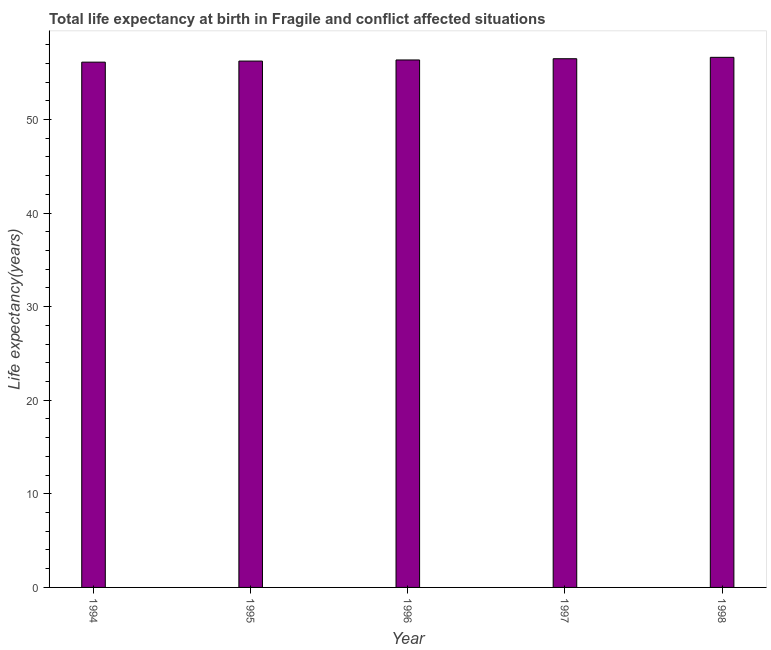Does the graph contain any zero values?
Give a very brief answer. No. Does the graph contain grids?
Offer a very short reply. No. What is the title of the graph?
Provide a succinct answer. Total life expectancy at birth in Fragile and conflict affected situations. What is the label or title of the X-axis?
Give a very brief answer. Year. What is the label or title of the Y-axis?
Offer a very short reply. Life expectancy(years). What is the life expectancy at birth in 1995?
Your answer should be very brief. 56.25. Across all years, what is the maximum life expectancy at birth?
Your answer should be compact. 56.65. Across all years, what is the minimum life expectancy at birth?
Provide a short and direct response. 56.13. In which year was the life expectancy at birth maximum?
Provide a succinct answer. 1998. In which year was the life expectancy at birth minimum?
Your answer should be very brief. 1994. What is the sum of the life expectancy at birth?
Ensure brevity in your answer.  281.9. What is the difference between the life expectancy at birth in 1994 and 1995?
Provide a succinct answer. -0.12. What is the average life expectancy at birth per year?
Your answer should be compact. 56.38. What is the median life expectancy at birth?
Keep it short and to the point. 56.37. Do a majority of the years between 1997 and 1996 (inclusive) have life expectancy at birth greater than 22 years?
Give a very brief answer. No. Is the life expectancy at birth in 1994 less than that in 1996?
Make the answer very short. Yes. Is the difference between the life expectancy at birth in 1995 and 1997 greater than the difference between any two years?
Your answer should be very brief. No. What is the difference between the highest and the second highest life expectancy at birth?
Provide a short and direct response. 0.15. What is the difference between the highest and the lowest life expectancy at birth?
Give a very brief answer. 0.51. How many bars are there?
Ensure brevity in your answer.  5. What is the Life expectancy(years) of 1994?
Ensure brevity in your answer.  56.13. What is the Life expectancy(years) in 1995?
Make the answer very short. 56.25. What is the Life expectancy(years) in 1996?
Ensure brevity in your answer.  56.37. What is the Life expectancy(years) in 1997?
Give a very brief answer. 56.5. What is the Life expectancy(years) of 1998?
Provide a short and direct response. 56.65. What is the difference between the Life expectancy(years) in 1994 and 1995?
Offer a very short reply. -0.11. What is the difference between the Life expectancy(years) in 1994 and 1996?
Ensure brevity in your answer.  -0.23. What is the difference between the Life expectancy(years) in 1994 and 1997?
Your answer should be compact. -0.37. What is the difference between the Life expectancy(years) in 1994 and 1998?
Give a very brief answer. -0.51. What is the difference between the Life expectancy(years) in 1995 and 1996?
Give a very brief answer. -0.12. What is the difference between the Life expectancy(years) in 1995 and 1997?
Your response must be concise. -0.25. What is the difference between the Life expectancy(years) in 1995 and 1998?
Offer a terse response. -0.4. What is the difference between the Life expectancy(years) in 1996 and 1997?
Make the answer very short. -0.13. What is the difference between the Life expectancy(years) in 1996 and 1998?
Ensure brevity in your answer.  -0.28. What is the difference between the Life expectancy(years) in 1997 and 1998?
Your response must be concise. -0.15. What is the ratio of the Life expectancy(years) in 1994 to that in 1995?
Your response must be concise. 1. What is the ratio of the Life expectancy(years) in 1994 to that in 1996?
Provide a short and direct response. 1. What is the ratio of the Life expectancy(years) in 1994 to that in 1997?
Ensure brevity in your answer.  0.99. What is the ratio of the Life expectancy(years) in 1994 to that in 1998?
Your answer should be compact. 0.99. What is the ratio of the Life expectancy(years) in 1995 to that in 1996?
Your answer should be compact. 1. What is the ratio of the Life expectancy(years) in 1995 to that in 1997?
Give a very brief answer. 1. What is the ratio of the Life expectancy(years) in 1996 to that in 1998?
Provide a succinct answer. 0.99. 